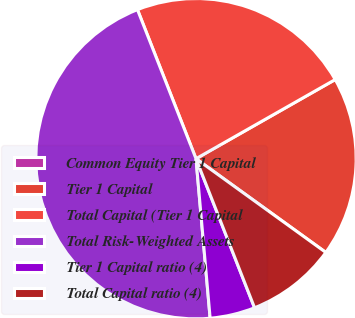Convert chart to OTSL. <chart><loc_0><loc_0><loc_500><loc_500><pie_chart><fcel>Common Equity Tier 1 Capital<fcel>Tier 1 Capital<fcel>Total Capital (Tier 1 Capital<fcel>Total Risk-Weighted Assets<fcel>Tier 1 Capital ratio (4)<fcel>Total Capital ratio (4)<nl><fcel>0.0%<fcel>18.18%<fcel>22.73%<fcel>45.45%<fcel>4.55%<fcel>9.09%<nl></chart> 